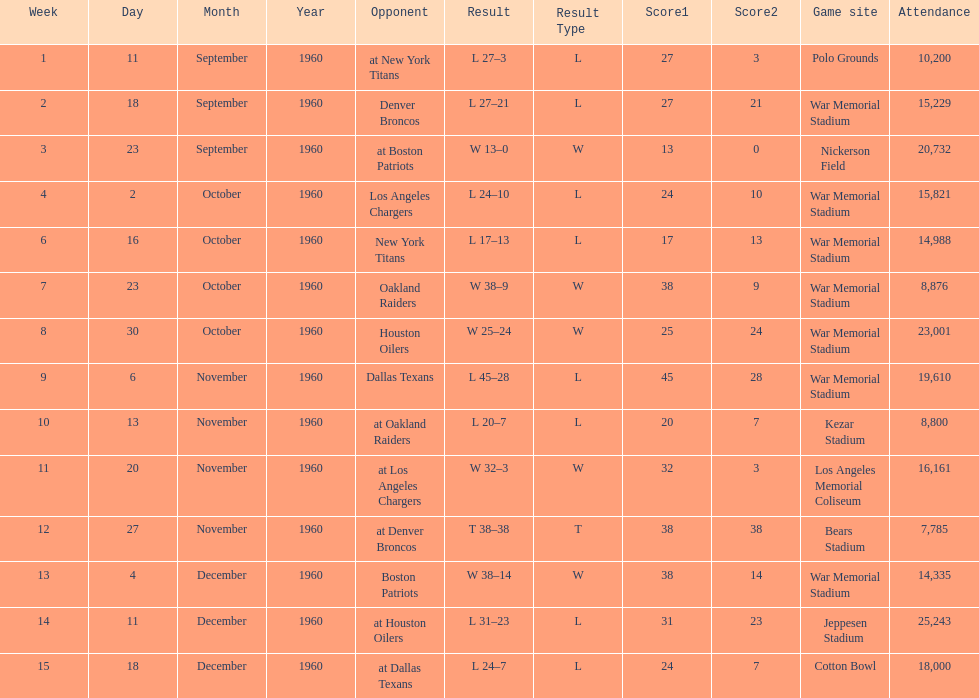Who was the opponent during for first week? New York Titans. 